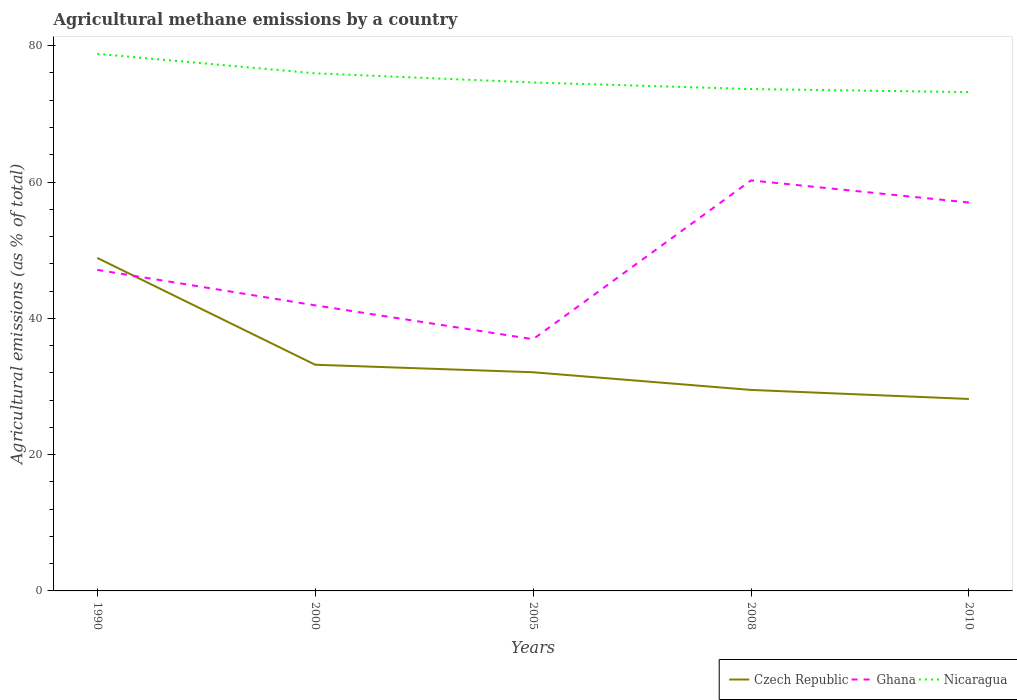How many different coloured lines are there?
Offer a terse response. 3. Is the number of lines equal to the number of legend labels?
Ensure brevity in your answer.  Yes. Across all years, what is the maximum amount of agricultural methane emitted in Czech Republic?
Provide a succinct answer. 28.17. In which year was the amount of agricultural methane emitted in Czech Republic maximum?
Provide a short and direct response. 2010. What is the total amount of agricultural methane emitted in Czech Republic in the graph?
Your response must be concise. 5.02. What is the difference between the highest and the second highest amount of agricultural methane emitted in Czech Republic?
Make the answer very short. 20.7. Is the amount of agricultural methane emitted in Nicaragua strictly greater than the amount of agricultural methane emitted in Ghana over the years?
Your response must be concise. No. How many lines are there?
Keep it short and to the point. 3. Are the values on the major ticks of Y-axis written in scientific E-notation?
Offer a very short reply. No. Does the graph contain any zero values?
Your response must be concise. No. How many legend labels are there?
Give a very brief answer. 3. What is the title of the graph?
Offer a very short reply. Agricultural methane emissions by a country. What is the label or title of the X-axis?
Give a very brief answer. Years. What is the label or title of the Y-axis?
Keep it short and to the point. Agricultural emissions (as % of total). What is the Agricultural emissions (as % of total) in Czech Republic in 1990?
Make the answer very short. 48.86. What is the Agricultural emissions (as % of total) of Ghana in 1990?
Your response must be concise. 47.11. What is the Agricultural emissions (as % of total) in Nicaragua in 1990?
Offer a terse response. 78.81. What is the Agricultural emissions (as % of total) in Czech Republic in 2000?
Provide a succinct answer. 33.19. What is the Agricultural emissions (as % of total) of Ghana in 2000?
Your answer should be very brief. 41.9. What is the Agricultural emissions (as % of total) of Nicaragua in 2000?
Offer a very short reply. 75.95. What is the Agricultural emissions (as % of total) of Czech Republic in 2005?
Offer a very short reply. 32.09. What is the Agricultural emissions (as % of total) in Ghana in 2005?
Keep it short and to the point. 36.94. What is the Agricultural emissions (as % of total) in Nicaragua in 2005?
Your response must be concise. 74.61. What is the Agricultural emissions (as % of total) in Czech Republic in 2008?
Ensure brevity in your answer.  29.49. What is the Agricultural emissions (as % of total) in Ghana in 2008?
Offer a terse response. 60.24. What is the Agricultural emissions (as % of total) of Nicaragua in 2008?
Your answer should be compact. 73.64. What is the Agricultural emissions (as % of total) in Czech Republic in 2010?
Provide a short and direct response. 28.17. What is the Agricultural emissions (as % of total) of Ghana in 2010?
Ensure brevity in your answer.  56.99. What is the Agricultural emissions (as % of total) in Nicaragua in 2010?
Keep it short and to the point. 73.19. Across all years, what is the maximum Agricultural emissions (as % of total) in Czech Republic?
Keep it short and to the point. 48.86. Across all years, what is the maximum Agricultural emissions (as % of total) of Ghana?
Give a very brief answer. 60.24. Across all years, what is the maximum Agricultural emissions (as % of total) in Nicaragua?
Keep it short and to the point. 78.81. Across all years, what is the minimum Agricultural emissions (as % of total) of Czech Republic?
Your answer should be compact. 28.17. Across all years, what is the minimum Agricultural emissions (as % of total) of Ghana?
Ensure brevity in your answer.  36.94. Across all years, what is the minimum Agricultural emissions (as % of total) in Nicaragua?
Provide a succinct answer. 73.19. What is the total Agricultural emissions (as % of total) in Czech Republic in the graph?
Give a very brief answer. 171.8. What is the total Agricultural emissions (as % of total) of Ghana in the graph?
Offer a terse response. 243.18. What is the total Agricultural emissions (as % of total) of Nicaragua in the graph?
Your answer should be compact. 376.2. What is the difference between the Agricultural emissions (as % of total) of Czech Republic in 1990 and that in 2000?
Offer a terse response. 15.67. What is the difference between the Agricultural emissions (as % of total) of Ghana in 1990 and that in 2000?
Provide a short and direct response. 5.2. What is the difference between the Agricultural emissions (as % of total) in Nicaragua in 1990 and that in 2000?
Offer a very short reply. 2.86. What is the difference between the Agricultural emissions (as % of total) of Czech Republic in 1990 and that in 2005?
Your answer should be compact. 16.78. What is the difference between the Agricultural emissions (as % of total) in Ghana in 1990 and that in 2005?
Your answer should be compact. 10.17. What is the difference between the Agricultural emissions (as % of total) in Nicaragua in 1990 and that in 2005?
Your answer should be compact. 4.2. What is the difference between the Agricultural emissions (as % of total) in Czech Republic in 1990 and that in 2008?
Offer a terse response. 19.37. What is the difference between the Agricultural emissions (as % of total) in Ghana in 1990 and that in 2008?
Offer a very short reply. -13.13. What is the difference between the Agricultural emissions (as % of total) in Nicaragua in 1990 and that in 2008?
Provide a short and direct response. 5.17. What is the difference between the Agricultural emissions (as % of total) of Czech Republic in 1990 and that in 2010?
Provide a succinct answer. 20.7. What is the difference between the Agricultural emissions (as % of total) in Ghana in 1990 and that in 2010?
Your answer should be very brief. -9.88. What is the difference between the Agricultural emissions (as % of total) in Nicaragua in 1990 and that in 2010?
Provide a short and direct response. 5.62. What is the difference between the Agricultural emissions (as % of total) in Czech Republic in 2000 and that in 2005?
Your response must be concise. 1.1. What is the difference between the Agricultural emissions (as % of total) in Ghana in 2000 and that in 2005?
Offer a very short reply. 4.97. What is the difference between the Agricultural emissions (as % of total) of Nicaragua in 2000 and that in 2005?
Give a very brief answer. 1.34. What is the difference between the Agricultural emissions (as % of total) in Czech Republic in 2000 and that in 2008?
Make the answer very short. 3.69. What is the difference between the Agricultural emissions (as % of total) in Ghana in 2000 and that in 2008?
Your answer should be compact. -18.34. What is the difference between the Agricultural emissions (as % of total) of Nicaragua in 2000 and that in 2008?
Offer a terse response. 2.31. What is the difference between the Agricultural emissions (as % of total) of Czech Republic in 2000 and that in 2010?
Give a very brief answer. 5.02. What is the difference between the Agricultural emissions (as % of total) in Ghana in 2000 and that in 2010?
Provide a short and direct response. -15.09. What is the difference between the Agricultural emissions (as % of total) of Nicaragua in 2000 and that in 2010?
Give a very brief answer. 2.76. What is the difference between the Agricultural emissions (as % of total) in Czech Republic in 2005 and that in 2008?
Keep it short and to the point. 2.59. What is the difference between the Agricultural emissions (as % of total) of Ghana in 2005 and that in 2008?
Provide a succinct answer. -23.3. What is the difference between the Agricultural emissions (as % of total) in Nicaragua in 2005 and that in 2008?
Keep it short and to the point. 0.96. What is the difference between the Agricultural emissions (as % of total) in Czech Republic in 2005 and that in 2010?
Make the answer very short. 3.92. What is the difference between the Agricultural emissions (as % of total) in Ghana in 2005 and that in 2010?
Your answer should be very brief. -20.06. What is the difference between the Agricultural emissions (as % of total) of Nicaragua in 2005 and that in 2010?
Provide a succinct answer. 1.42. What is the difference between the Agricultural emissions (as % of total) in Czech Republic in 2008 and that in 2010?
Your response must be concise. 1.33. What is the difference between the Agricultural emissions (as % of total) in Ghana in 2008 and that in 2010?
Make the answer very short. 3.25. What is the difference between the Agricultural emissions (as % of total) in Nicaragua in 2008 and that in 2010?
Your answer should be very brief. 0.45. What is the difference between the Agricultural emissions (as % of total) in Czech Republic in 1990 and the Agricultural emissions (as % of total) in Ghana in 2000?
Ensure brevity in your answer.  6.96. What is the difference between the Agricultural emissions (as % of total) in Czech Republic in 1990 and the Agricultural emissions (as % of total) in Nicaragua in 2000?
Give a very brief answer. -27.09. What is the difference between the Agricultural emissions (as % of total) of Ghana in 1990 and the Agricultural emissions (as % of total) of Nicaragua in 2000?
Offer a very short reply. -28.84. What is the difference between the Agricultural emissions (as % of total) in Czech Republic in 1990 and the Agricultural emissions (as % of total) in Ghana in 2005?
Your answer should be very brief. 11.93. What is the difference between the Agricultural emissions (as % of total) in Czech Republic in 1990 and the Agricultural emissions (as % of total) in Nicaragua in 2005?
Give a very brief answer. -25.75. What is the difference between the Agricultural emissions (as % of total) of Ghana in 1990 and the Agricultural emissions (as % of total) of Nicaragua in 2005?
Your answer should be very brief. -27.5. What is the difference between the Agricultural emissions (as % of total) of Czech Republic in 1990 and the Agricultural emissions (as % of total) of Ghana in 2008?
Your answer should be compact. -11.38. What is the difference between the Agricultural emissions (as % of total) in Czech Republic in 1990 and the Agricultural emissions (as % of total) in Nicaragua in 2008?
Provide a short and direct response. -24.78. What is the difference between the Agricultural emissions (as % of total) of Ghana in 1990 and the Agricultural emissions (as % of total) of Nicaragua in 2008?
Provide a succinct answer. -26.54. What is the difference between the Agricultural emissions (as % of total) in Czech Republic in 1990 and the Agricultural emissions (as % of total) in Ghana in 2010?
Your answer should be compact. -8.13. What is the difference between the Agricultural emissions (as % of total) in Czech Republic in 1990 and the Agricultural emissions (as % of total) in Nicaragua in 2010?
Your response must be concise. -24.33. What is the difference between the Agricultural emissions (as % of total) in Ghana in 1990 and the Agricultural emissions (as % of total) in Nicaragua in 2010?
Your answer should be very brief. -26.08. What is the difference between the Agricultural emissions (as % of total) in Czech Republic in 2000 and the Agricultural emissions (as % of total) in Ghana in 2005?
Your response must be concise. -3.75. What is the difference between the Agricultural emissions (as % of total) of Czech Republic in 2000 and the Agricultural emissions (as % of total) of Nicaragua in 2005?
Your answer should be compact. -41.42. What is the difference between the Agricultural emissions (as % of total) of Ghana in 2000 and the Agricultural emissions (as % of total) of Nicaragua in 2005?
Provide a short and direct response. -32.7. What is the difference between the Agricultural emissions (as % of total) in Czech Republic in 2000 and the Agricultural emissions (as % of total) in Ghana in 2008?
Your response must be concise. -27.05. What is the difference between the Agricultural emissions (as % of total) of Czech Republic in 2000 and the Agricultural emissions (as % of total) of Nicaragua in 2008?
Your response must be concise. -40.45. What is the difference between the Agricultural emissions (as % of total) of Ghana in 2000 and the Agricultural emissions (as % of total) of Nicaragua in 2008?
Make the answer very short. -31.74. What is the difference between the Agricultural emissions (as % of total) in Czech Republic in 2000 and the Agricultural emissions (as % of total) in Ghana in 2010?
Your answer should be compact. -23.8. What is the difference between the Agricultural emissions (as % of total) in Czech Republic in 2000 and the Agricultural emissions (as % of total) in Nicaragua in 2010?
Give a very brief answer. -40. What is the difference between the Agricultural emissions (as % of total) of Ghana in 2000 and the Agricultural emissions (as % of total) of Nicaragua in 2010?
Ensure brevity in your answer.  -31.29. What is the difference between the Agricultural emissions (as % of total) of Czech Republic in 2005 and the Agricultural emissions (as % of total) of Ghana in 2008?
Give a very brief answer. -28.15. What is the difference between the Agricultural emissions (as % of total) of Czech Republic in 2005 and the Agricultural emissions (as % of total) of Nicaragua in 2008?
Your answer should be very brief. -41.56. What is the difference between the Agricultural emissions (as % of total) in Ghana in 2005 and the Agricultural emissions (as % of total) in Nicaragua in 2008?
Provide a short and direct response. -36.71. What is the difference between the Agricultural emissions (as % of total) in Czech Republic in 2005 and the Agricultural emissions (as % of total) in Ghana in 2010?
Provide a succinct answer. -24.9. What is the difference between the Agricultural emissions (as % of total) of Czech Republic in 2005 and the Agricultural emissions (as % of total) of Nicaragua in 2010?
Your answer should be compact. -41.11. What is the difference between the Agricultural emissions (as % of total) of Ghana in 2005 and the Agricultural emissions (as % of total) of Nicaragua in 2010?
Your answer should be very brief. -36.26. What is the difference between the Agricultural emissions (as % of total) of Czech Republic in 2008 and the Agricultural emissions (as % of total) of Ghana in 2010?
Give a very brief answer. -27.5. What is the difference between the Agricultural emissions (as % of total) in Czech Republic in 2008 and the Agricultural emissions (as % of total) in Nicaragua in 2010?
Offer a terse response. -43.7. What is the difference between the Agricultural emissions (as % of total) in Ghana in 2008 and the Agricultural emissions (as % of total) in Nicaragua in 2010?
Ensure brevity in your answer.  -12.95. What is the average Agricultural emissions (as % of total) in Czech Republic per year?
Offer a very short reply. 34.36. What is the average Agricultural emissions (as % of total) of Ghana per year?
Your answer should be compact. 48.64. What is the average Agricultural emissions (as % of total) in Nicaragua per year?
Provide a short and direct response. 75.24. In the year 1990, what is the difference between the Agricultural emissions (as % of total) of Czech Republic and Agricultural emissions (as % of total) of Ghana?
Give a very brief answer. 1.75. In the year 1990, what is the difference between the Agricultural emissions (as % of total) in Czech Republic and Agricultural emissions (as % of total) in Nicaragua?
Provide a short and direct response. -29.95. In the year 1990, what is the difference between the Agricultural emissions (as % of total) of Ghana and Agricultural emissions (as % of total) of Nicaragua?
Your response must be concise. -31.7. In the year 2000, what is the difference between the Agricultural emissions (as % of total) in Czech Republic and Agricultural emissions (as % of total) in Ghana?
Provide a succinct answer. -8.72. In the year 2000, what is the difference between the Agricultural emissions (as % of total) of Czech Republic and Agricultural emissions (as % of total) of Nicaragua?
Provide a succinct answer. -42.76. In the year 2000, what is the difference between the Agricultural emissions (as % of total) of Ghana and Agricultural emissions (as % of total) of Nicaragua?
Keep it short and to the point. -34.04. In the year 2005, what is the difference between the Agricultural emissions (as % of total) of Czech Republic and Agricultural emissions (as % of total) of Ghana?
Give a very brief answer. -4.85. In the year 2005, what is the difference between the Agricultural emissions (as % of total) of Czech Republic and Agricultural emissions (as % of total) of Nicaragua?
Make the answer very short. -42.52. In the year 2005, what is the difference between the Agricultural emissions (as % of total) of Ghana and Agricultural emissions (as % of total) of Nicaragua?
Ensure brevity in your answer.  -37.67. In the year 2008, what is the difference between the Agricultural emissions (as % of total) of Czech Republic and Agricultural emissions (as % of total) of Ghana?
Give a very brief answer. -30.75. In the year 2008, what is the difference between the Agricultural emissions (as % of total) in Czech Republic and Agricultural emissions (as % of total) in Nicaragua?
Your answer should be compact. -44.15. In the year 2008, what is the difference between the Agricultural emissions (as % of total) in Ghana and Agricultural emissions (as % of total) in Nicaragua?
Offer a terse response. -13.4. In the year 2010, what is the difference between the Agricultural emissions (as % of total) of Czech Republic and Agricultural emissions (as % of total) of Ghana?
Your answer should be compact. -28.82. In the year 2010, what is the difference between the Agricultural emissions (as % of total) in Czech Republic and Agricultural emissions (as % of total) in Nicaragua?
Provide a short and direct response. -45.03. In the year 2010, what is the difference between the Agricultural emissions (as % of total) of Ghana and Agricultural emissions (as % of total) of Nicaragua?
Offer a very short reply. -16.2. What is the ratio of the Agricultural emissions (as % of total) in Czech Republic in 1990 to that in 2000?
Offer a very short reply. 1.47. What is the ratio of the Agricultural emissions (as % of total) in Ghana in 1990 to that in 2000?
Provide a succinct answer. 1.12. What is the ratio of the Agricultural emissions (as % of total) of Nicaragua in 1990 to that in 2000?
Give a very brief answer. 1.04. What is the ratio of the Agricultural emissions (as % of total) in Czech Republic in 1990 to that in 2005?
Offer a terse response. 1.52. What is the ratio of the Agricultural emissions (as % of total) of Ghana in 1990 to that in 2005?
Your response must be concise. 1.28. What is the ratio of the Agricultural emissions (as % of total) of Nicaragua in 1990 to that in 2005?
Offer a very short reply. 1.06. What is the ratio of the Agricultural emissions (as % of total) of Czech Republic in 1990 to that in 2008?
Your answer should be very brief. 1.66. What is the ratio of the Agricultural emissions (as % of total) of Ghana in 1990 to that in 2008?
Make the answer very short. 0.78. What is the ratio of the Agricultural emissions (as % of total) of Nicaragua in 1990 to that in 2008?
Provide a succinct answer. 1.07. What is the ratio of the Agricultural emissions (as % of total) in Czech Republic in 1990 to that in 2010?
Your answer should be compact. 1.73. What is the ratio of the Agricultural emissions (as % of total) in Ghana in 1990 to that in 2010?
Provide a succinct answer. 0.83. What is the ratio of the Agricultural emissions (as % of total) of Nicaragua in 1990 to that in 2010?
Your response must be concise. 1.08. What is the ratio of the Agricultural emissions (as % of total) in Czech Republic in 2000 to that in 2005?
Your answer should be compact. 1.03. What is the ratio of the Agricultural emissions (as % of total) in Ghana in 2000 to that in 2005?
Ensure brevity in your answer.  1.13. What is the ratio of the Agricultural emissions (as % of total) in Nicaragua in 2000 to that in 2005?
Offer a very short reply. 1.02. What is the ratio of the Agricultural emissions (as % of total) of Czech Republic in 2000 to that in 2008?
Offer a terse response. 1.13. What is the ratio of the Agricultural emissions (as % of total) in Ghana in 2000 to that in 2008?
Offer a very short reply. 0.7. What is the ratio of the Agricultural emissions (as % of total) in Nicaragua in 2000 to that in 2008?
Provide a succinct answer. 1.03. What is the ratio of the Agricultural emissions (as % of total) of Czech Republic in 2000 to that in 2010?
Your answer should be very brief. 1.18. What is the ratio of the Agricultural emissions (as % of total) of Ghana in 2000 to that in 2010?
Make the answer very short. 0.74. What is the ratio of the Agricultural emissions (as % of total) of Nicaragua in 2000 to that in 2010?
Offer a very short reply. 1.04. What is the ratio of the Agricultural emissions (as % of total) in Czech Republic in 2005 to that in 2008?
Your response must be concise. 1.09. What is the ratio of the Agricultural emissions (as % of total) of Ghana in 2005 to that in 2008?
Keep it short and to the point. 0.61. What is the ratio of the Agricultural emissions (as % of total) in Nicaragua in 2005 to that in 2008?
Give a very brief answer. 1.01. What is the ratio of the Agricultural emissions (as % of total) in Czech Republic in 2005 to that in 2010?
Provide a succinct answer. 1.14. What is the ratio of the Agricultural emissions (as % of total) of Ghana in 2005 to that in 2010?
Give a very brief answer. 0.65. What is the ratio of the Agricultural emissions (as % of total) in Nicaragua in 2005 to that in 2010?
Provide a short and direct response. 1.02. What is the ratio of the Agricultural emissions (as % of total) in Czech Republic in 2008 to that in 2010?
Give a very brief answer. 1.05. What is the ratio of the Agricultural emissions (as % of total) in Ghana in 2008 to that in 2010?
Your response must be concise. 1.06. What is the ratio of the Agricultural emissions (as % of total) of Nicaragua in 2008 to that in 2010?
Your answer should be very brief. 1.01. What is the difference between the highest and the second highest Agricultural emissions (as % of total) in Czech Republic?
Your answer should be very brief. 15.67. What is the difference between the highest and the second highest Agricultural emissions (as % of total) in Ghana?
Ensure brevity in your answer.  3.25. What is the difference between the highest and the second highest Agricultural emissions (as % of total) in Nicaragua?
Keep it short and to the point. 2.86. What is the difference between the highest and the lowest Agricultural emissions (as % of total) of Czech Republic?
Your answer should be very brief. 20.7. What is the difference between the highest and the lowest Agricultural emissions (as % of total) in Ghana?
Offer a very short reply. 23.3. What is the difference between the highest and the lowest Agricultural emissions (as % of total) of Nicaragua?
Provide a succinct answer. 5.62. 